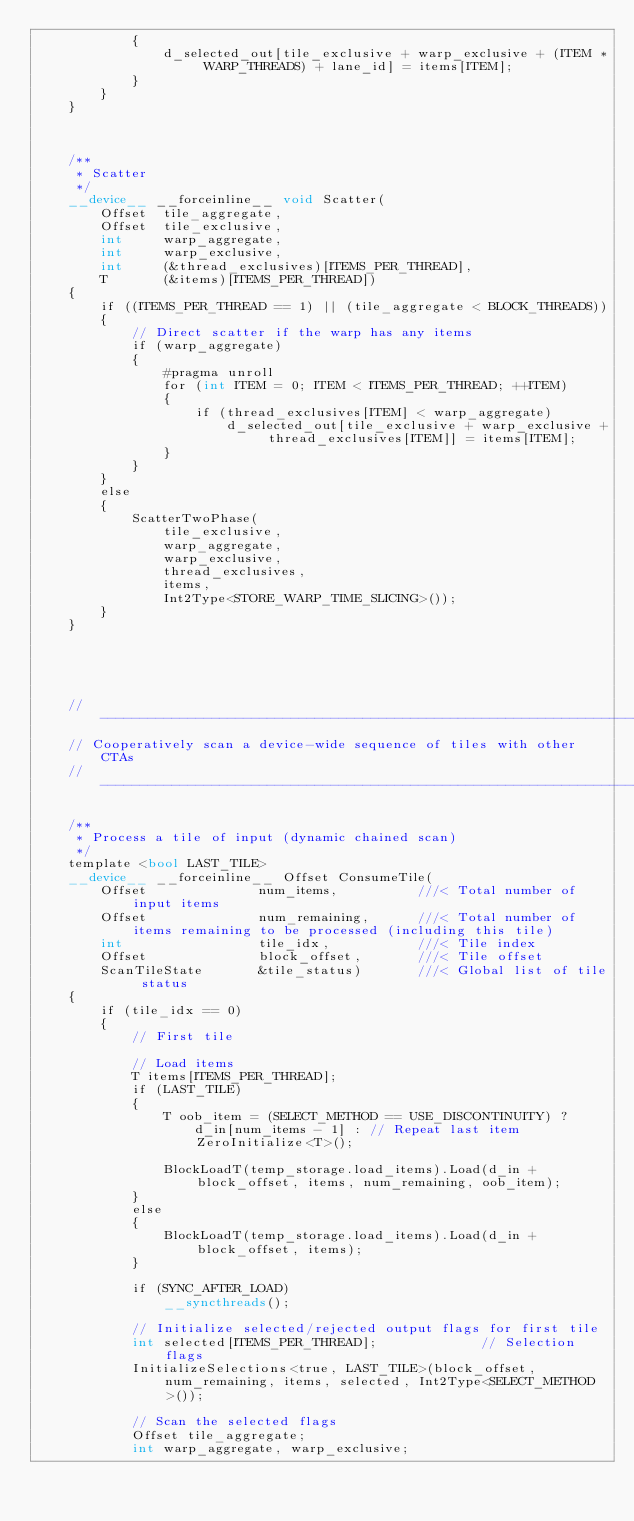Convert code to text. <code><loc_0><loc_0><loc_500><loc_500><_Cuda_>            {
                d_selected_out[tile_exclusive + warp_exclusive + (ITEM * WARP_THREADS) + lane_id] = items[ITEM];
            }
        }
    }



    /**
     * Scatter
     */
    __device__ __forceinline__ void Scatter(
        Offset  tile_aggregate,
        Offset  tile_exclusive,
        int     warp_aggregate,
        int     warp_exclusive,
        int     (&thread_exclusives)[ITEMS_PER_THREAD],
        T       (&items)[ITEMS_PER_THREAD])
    {
        if ((ITEMS_PER_THREAD == 1) || (tile_aggregate < BLOCK_THREADS))
        {
            // Direct scatter if the warp has any items
            if (warp_aggregate)
            {
                #pragma unroll
                for (int ITEM = 0; ITEM < ITEMS_PER_THREAD; ++ITEM)
                {
                    if (thread_exclusives[ITEM] < warp_aggregate)
                        d_selected_out[tile_exclusive + warp_exclusive + thread_exclusives[ITEM]] = items[ITEM];
                }
            }
        }
        else
        {
            ScatterTwoPhase(
                tile_exclusive,
                warp_aggregate,
                warp_exclusive,
                thread_exclusives,
                items,
                Int2Type<STORE_WARP_TIME_SLICING>());
        }
    }





    //---------------------------------------------------------------------
    // Cooperatively scan a device-wide sequence of tiles with other CTAs
    //---------------------------------------------------------------------

    /**
     * Process a tile of input (dynamic chained scan)
     */
    template <bool LAST_TILE>
    __device__ __forceinline__ Offset ConsumeTile(
        Offset              num_items,          ///< Total number of input items
        Offset              num_remaining,      ///< Total number of items remaining to be processed (including this tile)
        int                 tile_idx,           ///< Tile index
        Offset              block_offset,       ///< Tile offset
        ScanTileState       &tile_status)       ///< Global list of tile status
    {
        if (tile_idx == 0)
        {
            // First tile

            // Load items
            T items[ITEMS_PER_THREAD];
            if (LAST_TILE)
            {
                T oob_item = (SELECT_METHOD == USE_DISCONTINUITY) ?
                    d_in[num_items - 1] : // Repeat last item
                    ZeroInitialize<T>();

                BlockLoadT(temp_storage.load_items).Load(d_in + block_offset, items, num_remaining, oob_item);
            }
            else
            {
                BlockLoadT(temp_storage.load_items).Load(d_in + block_offset, items);
            }

            if (SYNC_AFTER_LOAD)
                __syncthreads();

            // Initialize selected/rejected output flags for first tile
            int selected[ITEMS_PER_THREAD];             // Selection flags
            InitializeSelections<true, LAST_TILE>(block_offset, num_remaining, items, selected, Int2Type<SELECT_METHOD>());

            // Scan the selected flags
            Offset tile_aggregate;
            int warp_aggregate, warp_exclusive;</code> 